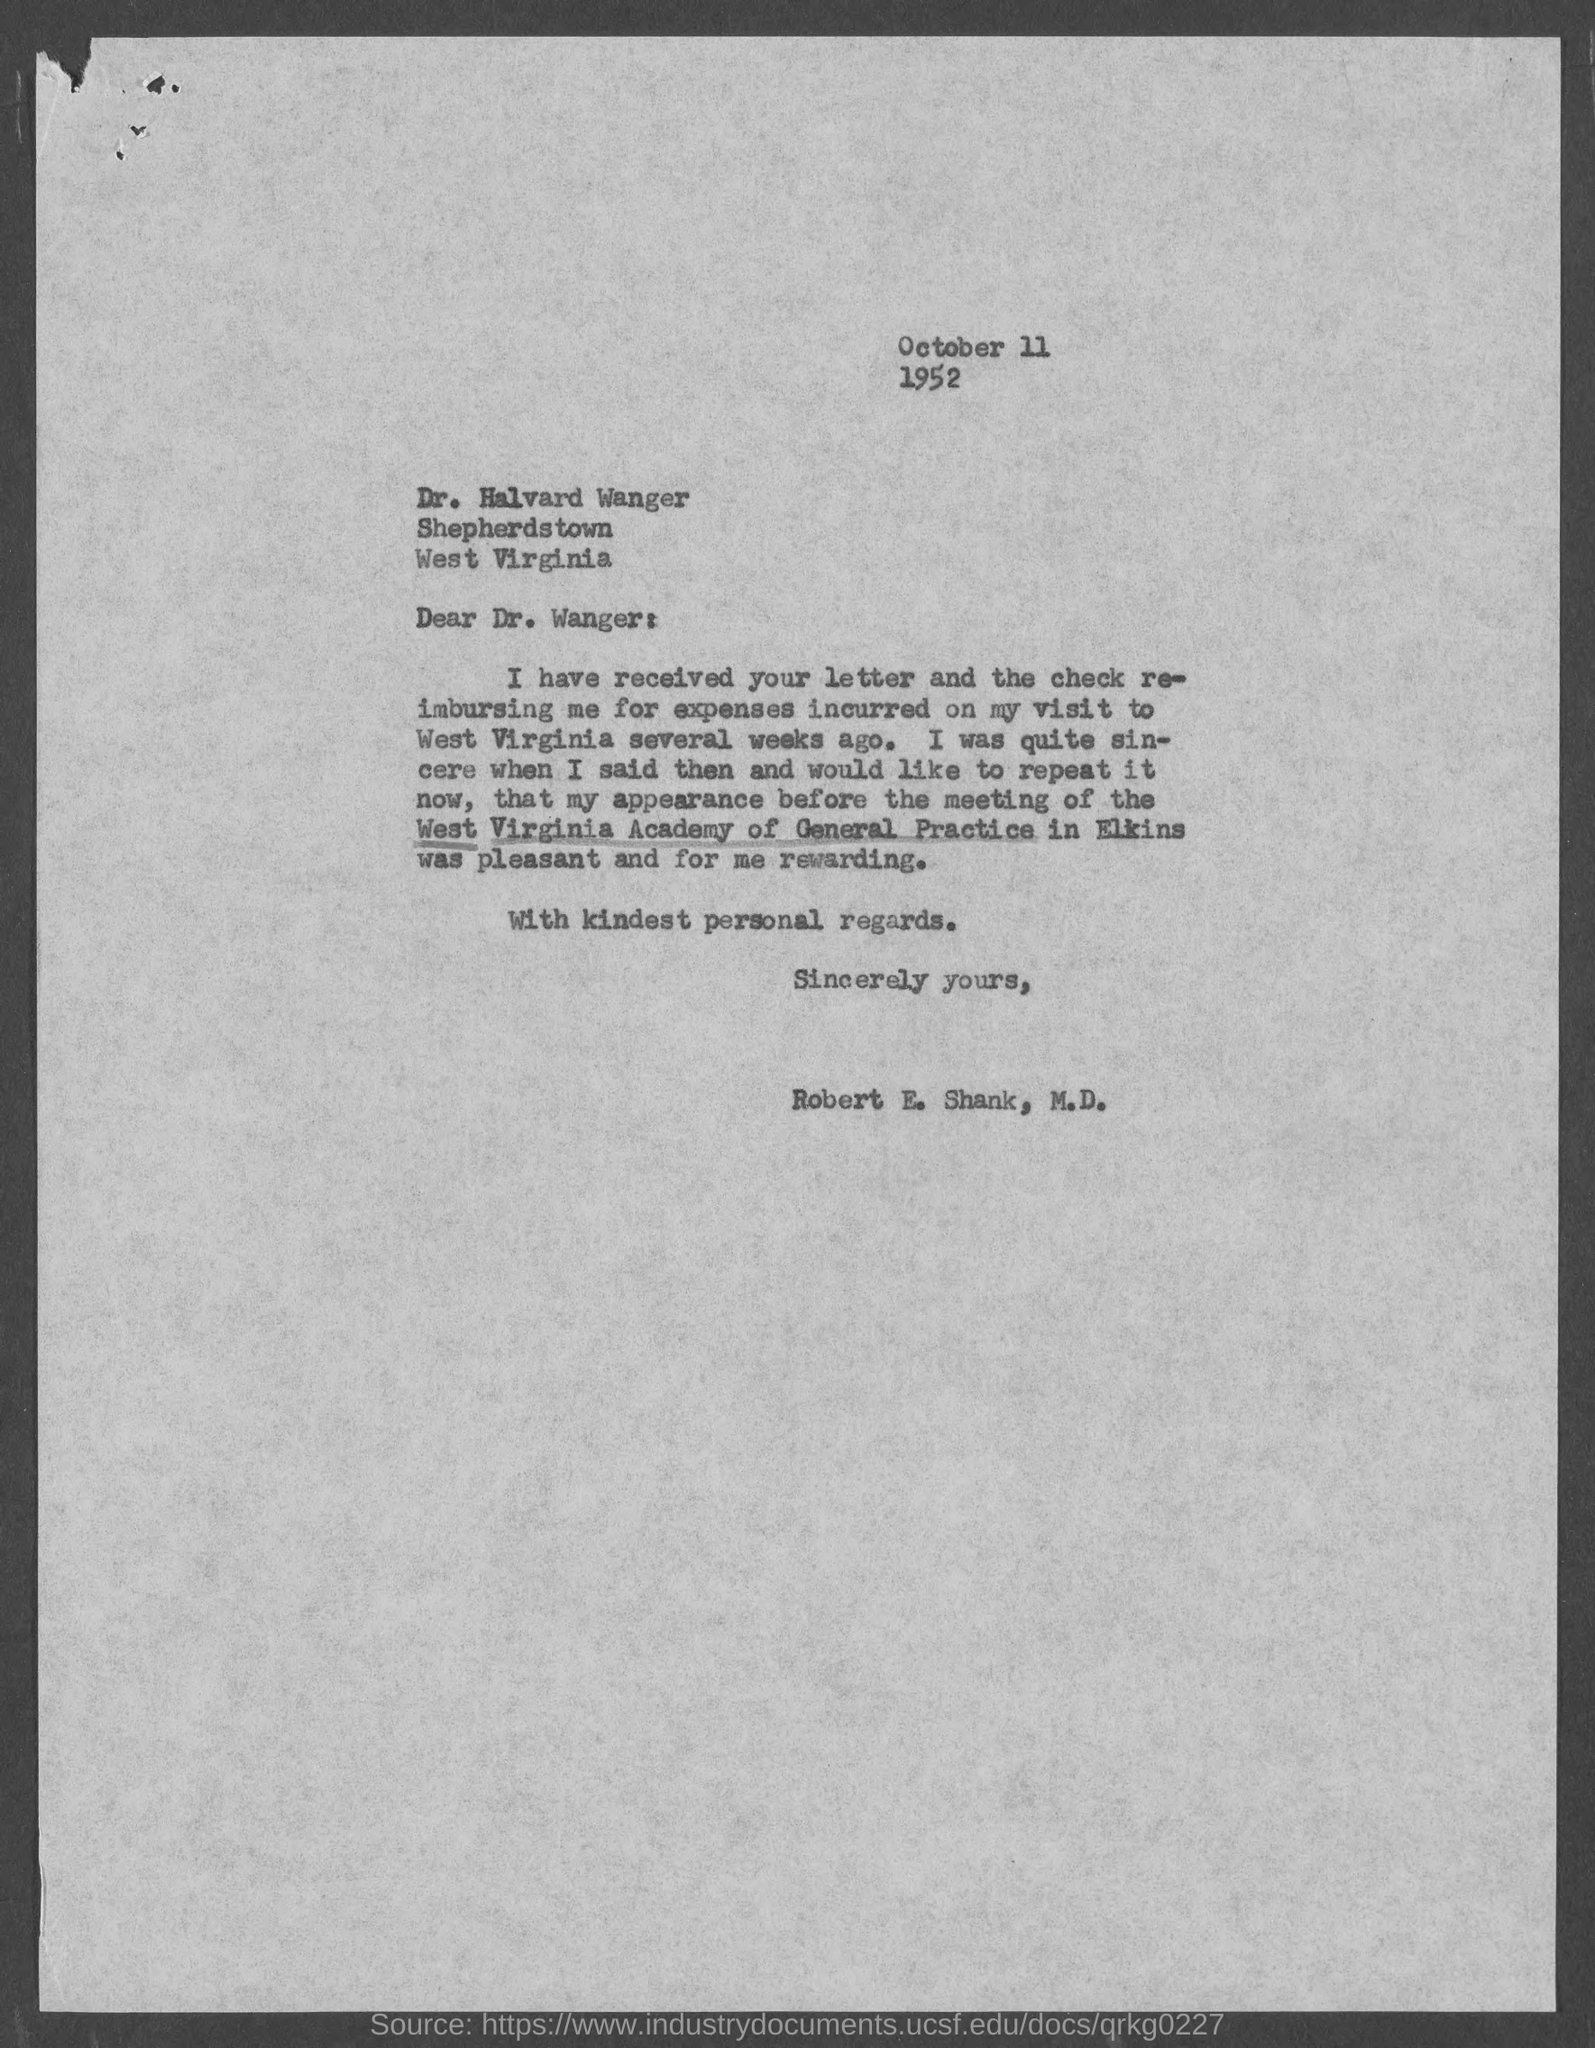To whom is the letter addressed?
Offer a very short reply. Dr. Wanger. Where was the meeting held?
Your answer should be very brief. Elkins. 